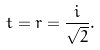Convert formula to latex. <formula><loc_0><loc_0><loc_500><loc_500>t = r = \frac { i } { \sqrt { 2 } } .</formula> 